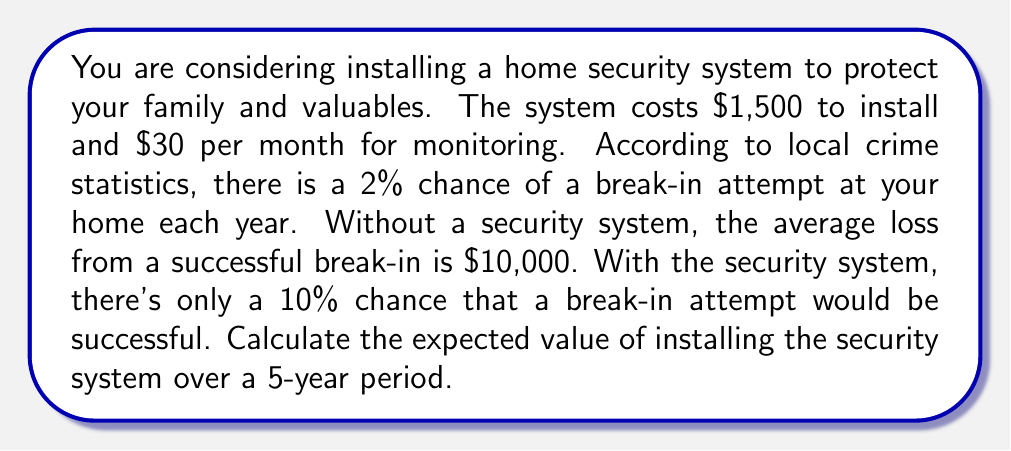Help me with this question. Let's break this down step-by-step:

1) First, let's calculate the cost of the security system over 5 years:
   Installation: $1,500
   Monthly monitoring: $30 × 12 months × 5 years = $1,800
   Total cost: $C = 1,500 + 1,800 = $3,300

2) Now, let's calculate the expected loss without the security system:
   Probability of break-in per year: $p = 0.02$
   Expected number of break-ins in 5 years: $0.02 × 5 = 0.1$
   Expected loss: $E_1 = 0.1 × $10,000 = $1,000$

3) With the security system:
   Probability of successful break-in: $0.02 × 0.1 = 0.002$ per year
   Expected number of successful break-ins in 5 years: $0.002 × 5 = 0.01$
   Expected loss: $E_2 = 0.01 × $10,000 = $100$

4) The difference in expected loss: $E_1 - E_2 = $1,000 - $100 = $900$

5) The expected value is the difference between the saved losses and the cost:
   $EV = $900 - $3,300 = -$2,400$

The negative expected value indicates that, purely from a financial standpoint, the security system costs more than the expected savings from prevented losses.
Answer: $-$2,400 